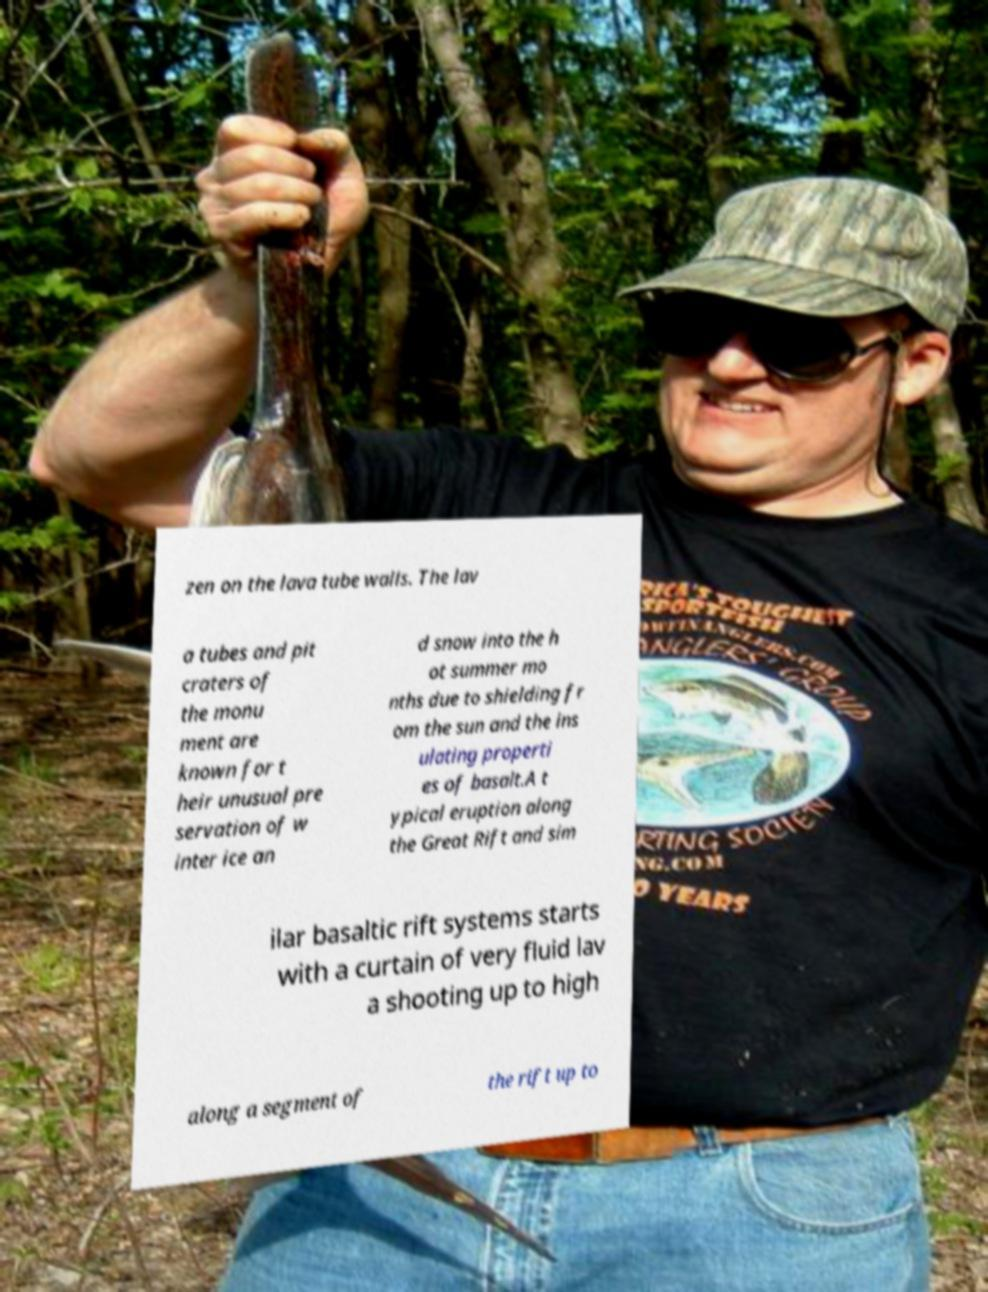For documentation purposes, I need the text within this image transcribed. Could you provide that? zen on the lava tube walls. The lav a tubes and pit craters of the monu ment are known for t heir unusual pre servation of w inter ice an d snow into the h ot summer mo nths due to shielding fr om the sun and the ins ulating properti es of basalt.A t ypical eruption along the Great Rift and sim ilar basaltic rift systems starts with a curtain of very fluid lav a shooting up to high along a segment of the rift up to 